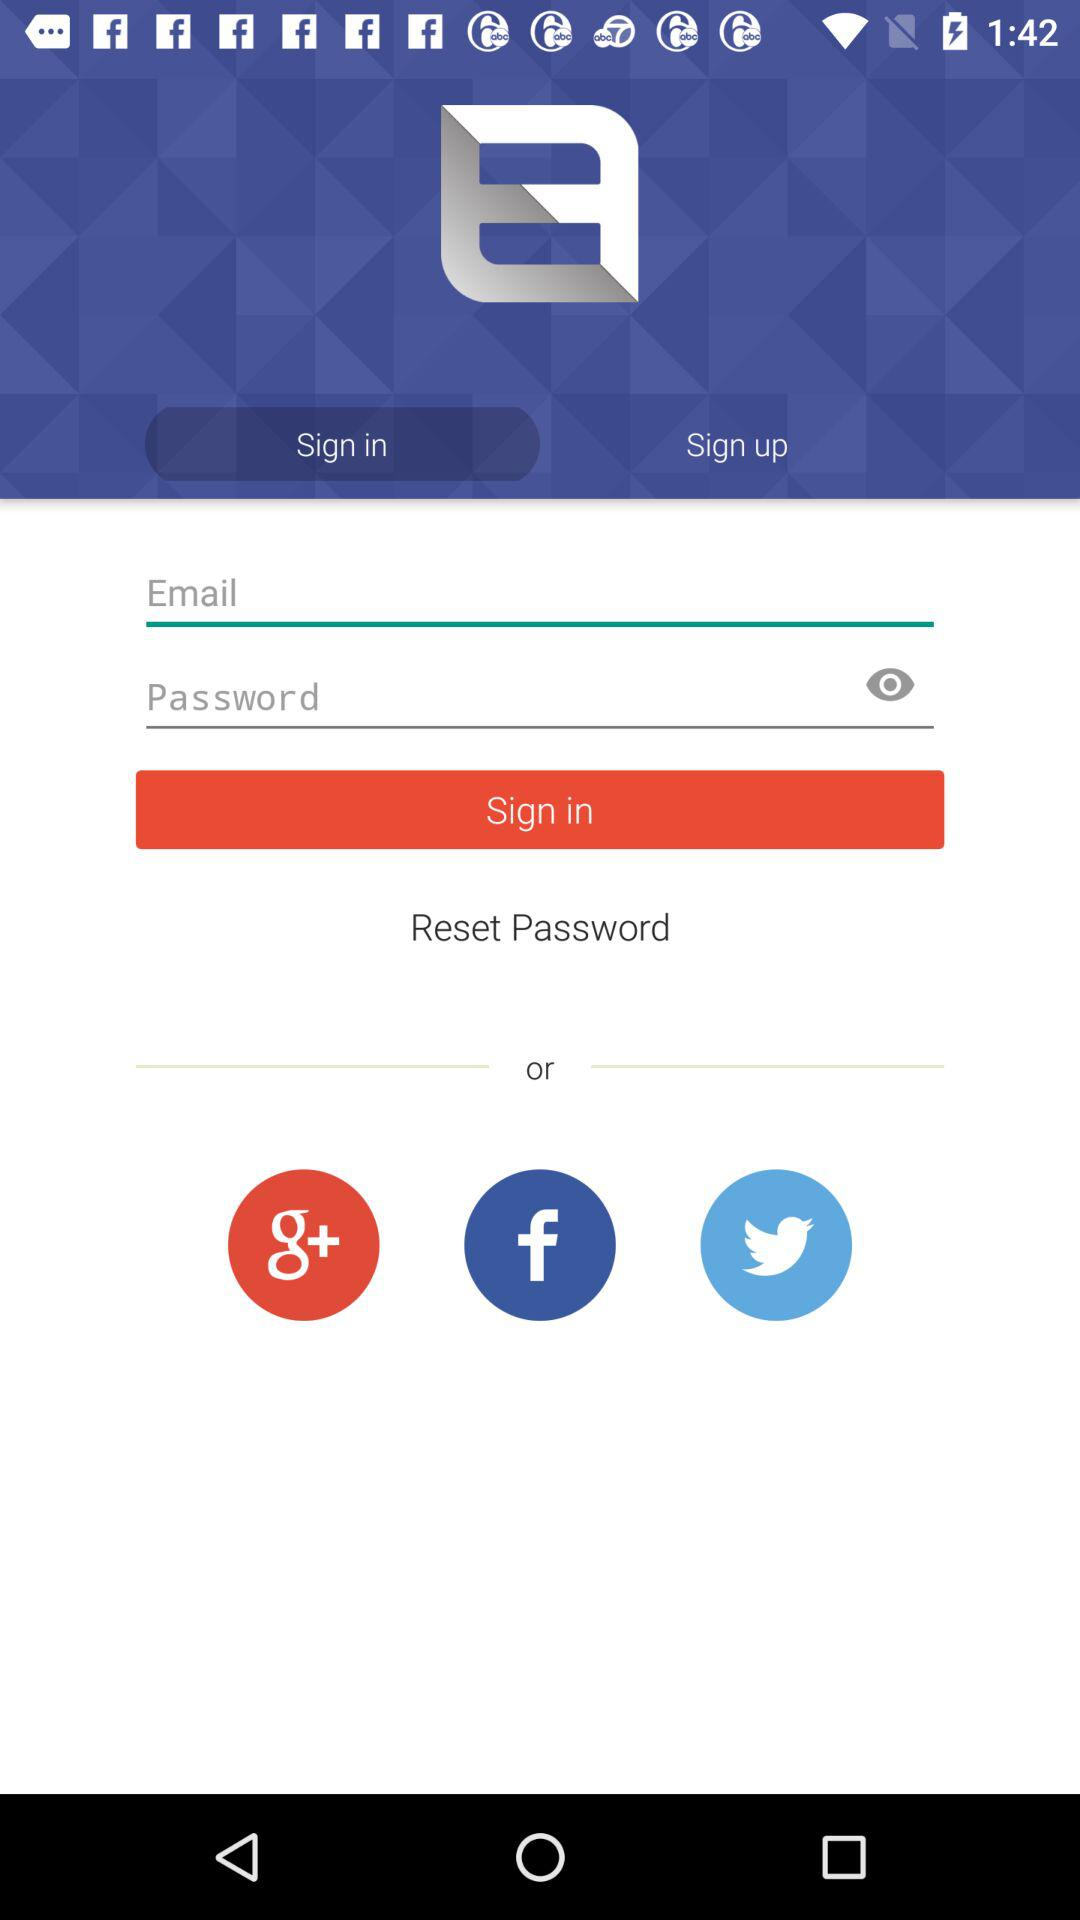Which application can be used to sign in? The applications that can be used to sign in are "Google+", "Facebook" and "Twitter". 